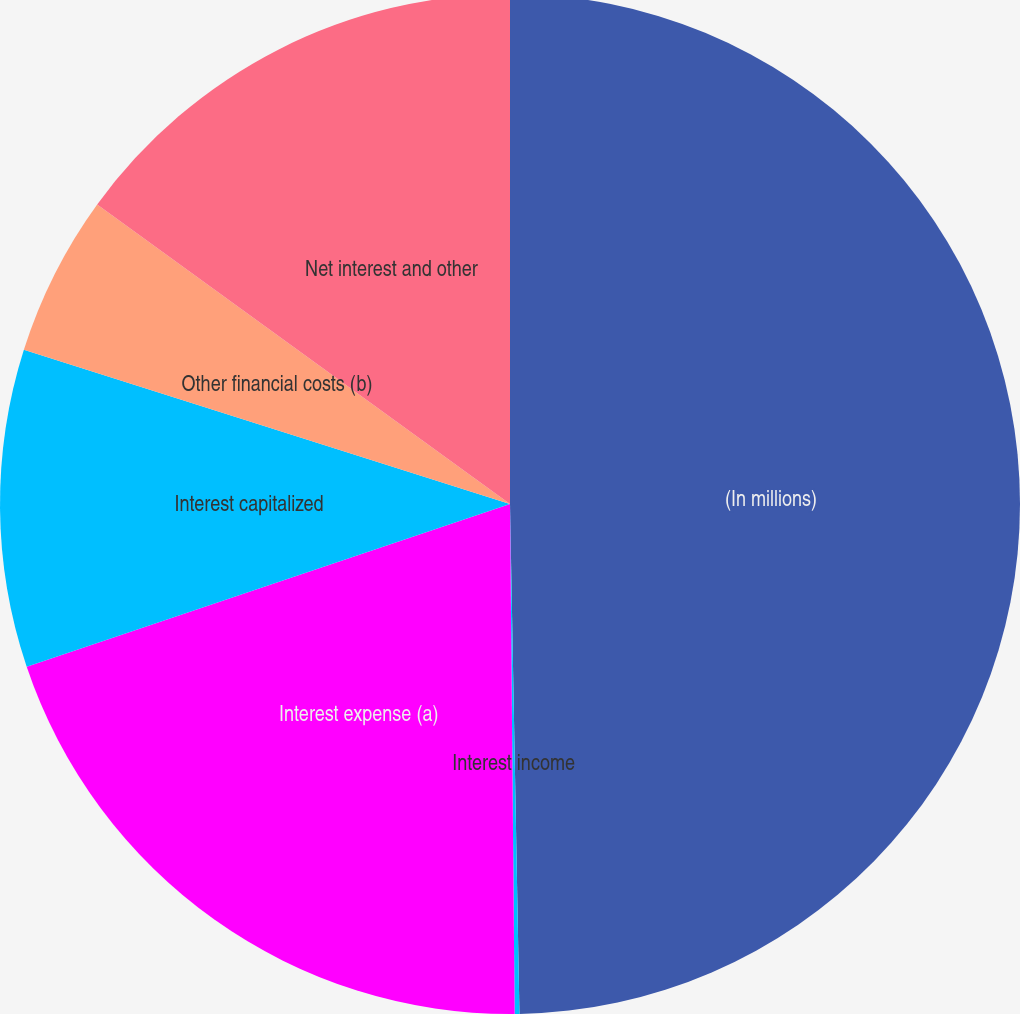<chart> <loc_0><loc_0><loc_500><loc_500><pie_chart><fcel>(In millions)<fcel>Interest income<fcel>Interest expense (a)<fcel>Interest capitalized<fcel>Other financial costs (b)<fcel>Net interest and other<nl><fcel>49.7%<fcel>0.15%<fcel>19.97%<fcel>10.06%<fcel>5.1%<fcel>15.01%<nl></chart> 